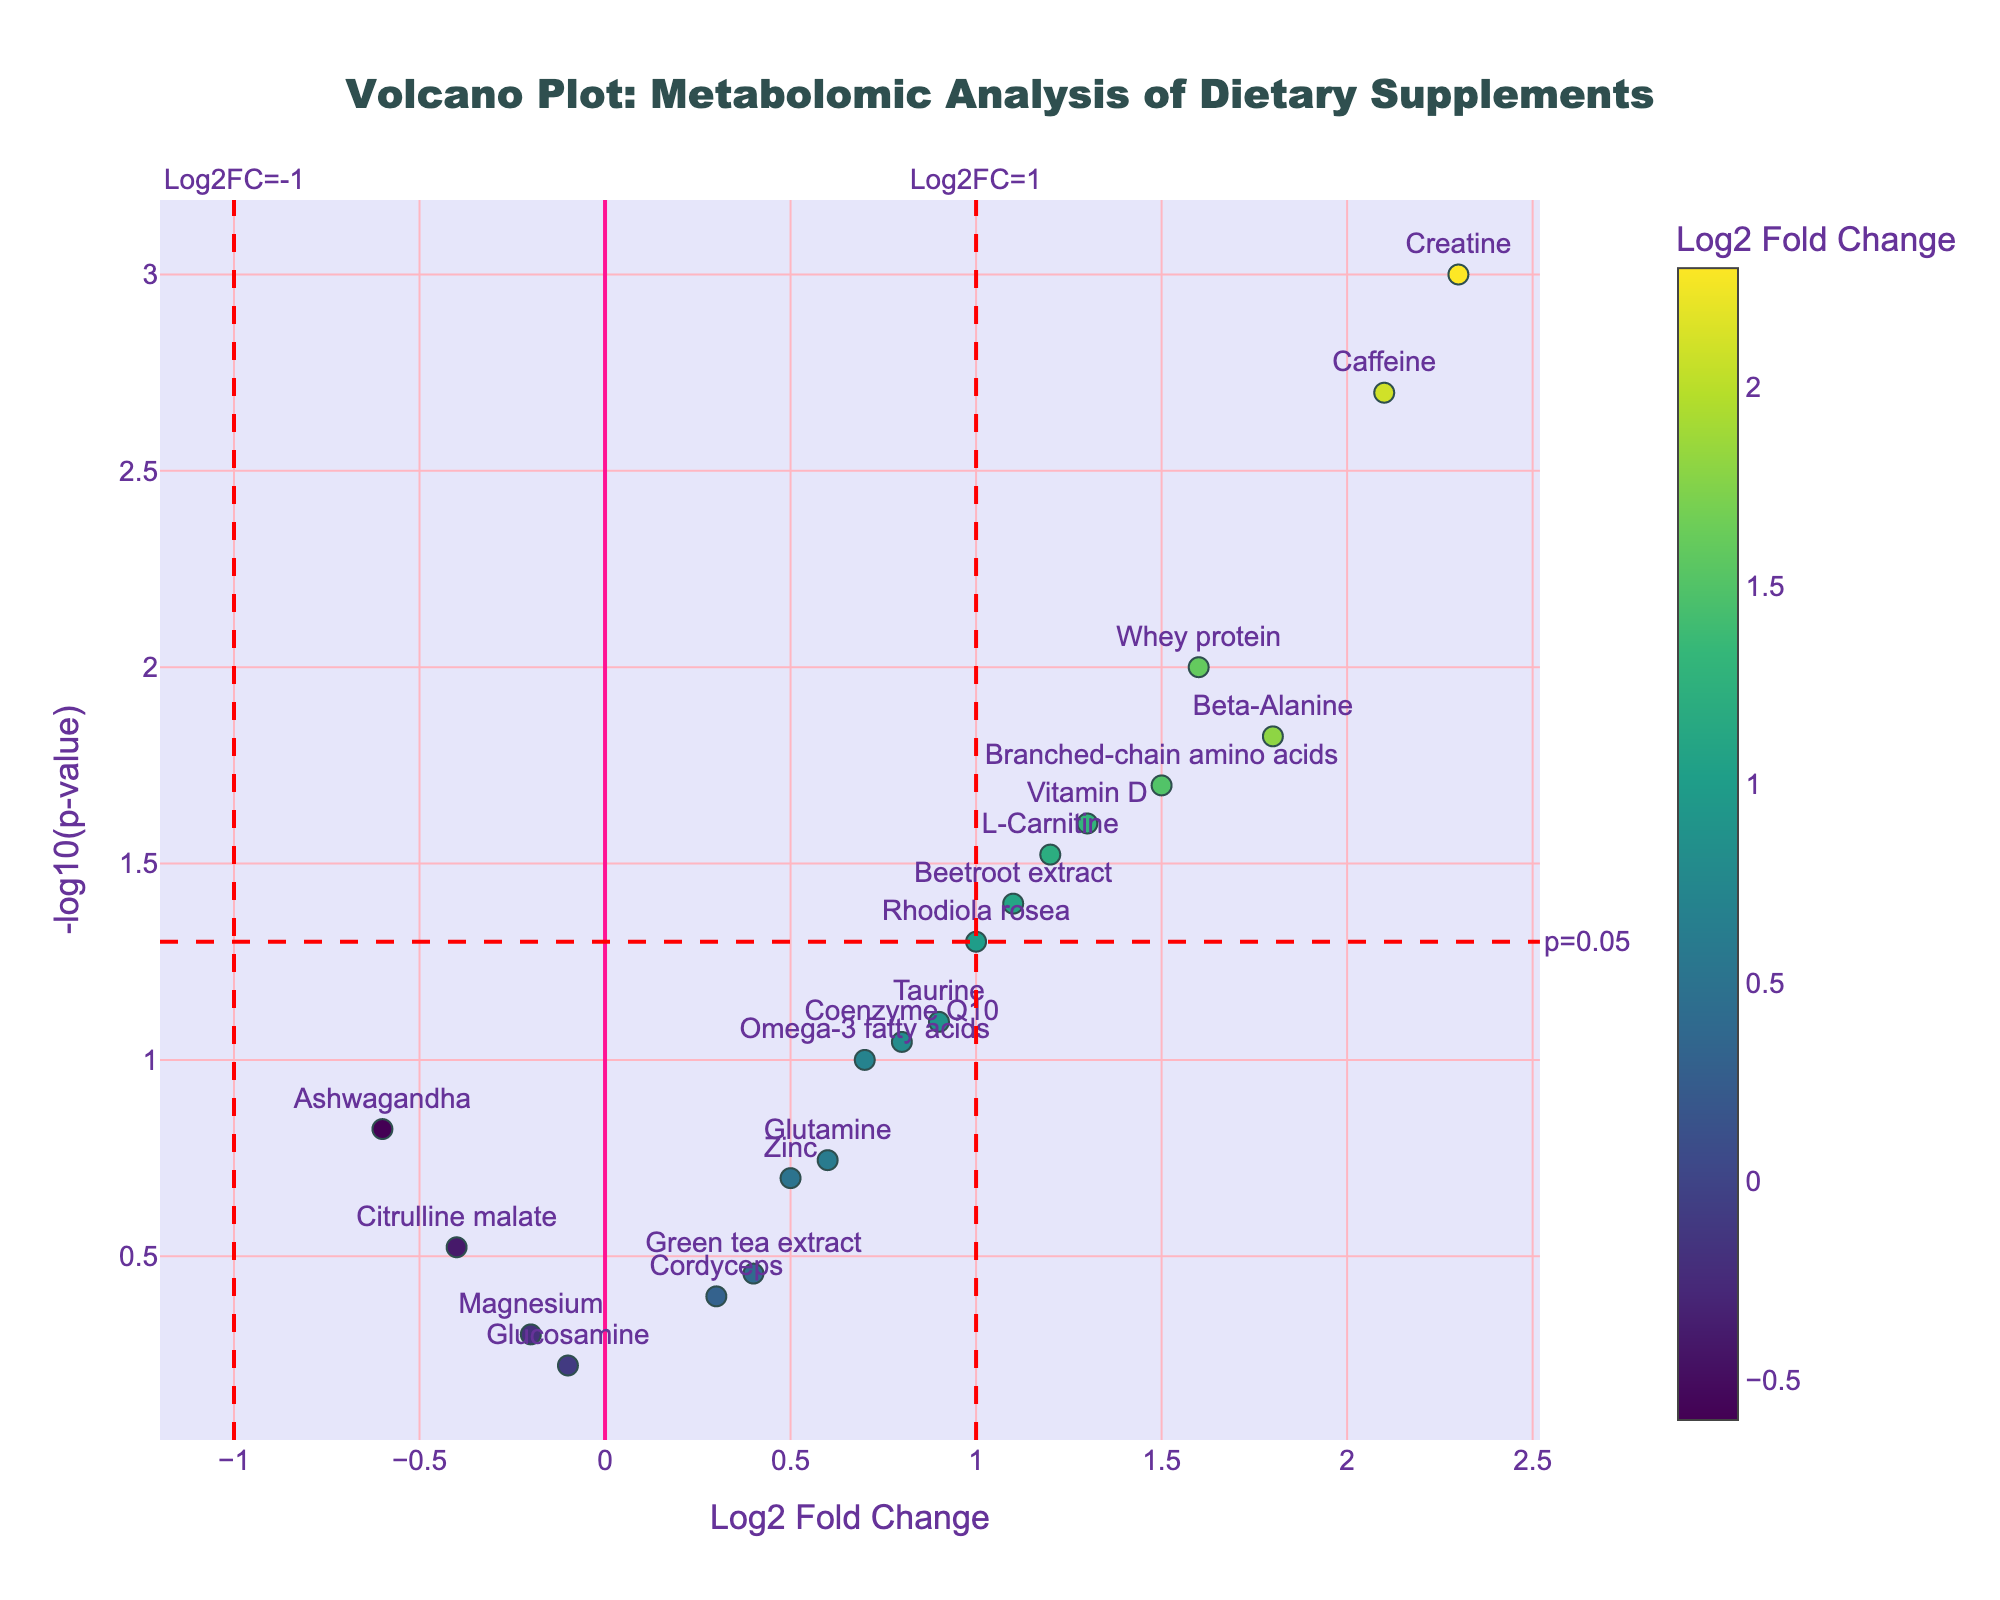what is the title of the figure? The figure title is usually presented at the top of the plot. In this case, it is written in large-sized and bold font. It says "Volcano Plot: Metabolomic Analysis of Dietary Supplements."
Answer: Volcano Plot: Metabolomic Analysis of Dietary Supplements what are the axes titles on the plot? Axes titles are typically displayed along the axes lines. The x-axis is titled "Log2 Fold Change," and the y-axis is titled "-log10(p-value)," indicating the values each axis represents.
Answer: Log2 Fold Change and -log10(p-value) how many data points are shown in the figure? Each data point corresponds to a metabolite in the data and is represented as a marker on the plot. Counting the markers will give the total number of data points, which is 20.
Answer: 20 which metabolite has the highest Log2 Fold Change? To determine this, you locate the rightmost point on the x-axis because it represents the highest positive Log2 Fold Change. The text label indicates this point is "Creatine" with 2.3.
Answer: Creatine how many metabolites have p-values below 0.05? A horizontal line representing a p-value threshold of 0.05 is annotated in the plot. Count the points above this line which gives 7 metabolites as having p-values below 0.05.
Answer: 7 what is the Log2 Fold Change and p-value for Beta-Alanine? Find Beta-Alanine in the plot and check the hover information or texts around the point. It indicates a Log2 Fold Change of 1.8 and a p-value of 0.015.
Answer: 1.8 and 0.015 which metabolites are marked within the significance threshold of Log2FC=1 and p-value<0.05? Filter the points based on the specified thresholds. Both vertical and horizontal lines help to identify these points: Creatine, Caffeine, Beta-Alanine, Branched-chain amino acids, and Whey protein.
Answer: Creatine, Caffeine, Beta-Alanine, Branched-chain amino acids, and Whey protein which metabolite has the smallest p-value, and what is it? The point at the highest position on the y-axis has the smallest p-value due to the -log10 transformation. It's Creatine with a p-value of 0.001.
Answer: Creatine and 0.001 what is the Log2 Fold Change for Rhodiola rosea? Locate Rhodiola rosea on the figure and check the x-axis value it aligns with. It shows a Log2 Fold Change of 1.0.
Answer: 1.0 how does the Log2 Fold Change of Beetroot extract compare with that of Citrulline malate? Check the x-axis positions for both metabolites. Beetroot extract is at 1.1, while Citrulline malate is at -0.4, making Beetroot extract greater than Citrulline malate in Log2 Fold Change.
Answer: Beetroot extract has a higher Log2 Fold Change than Citrulline malate 